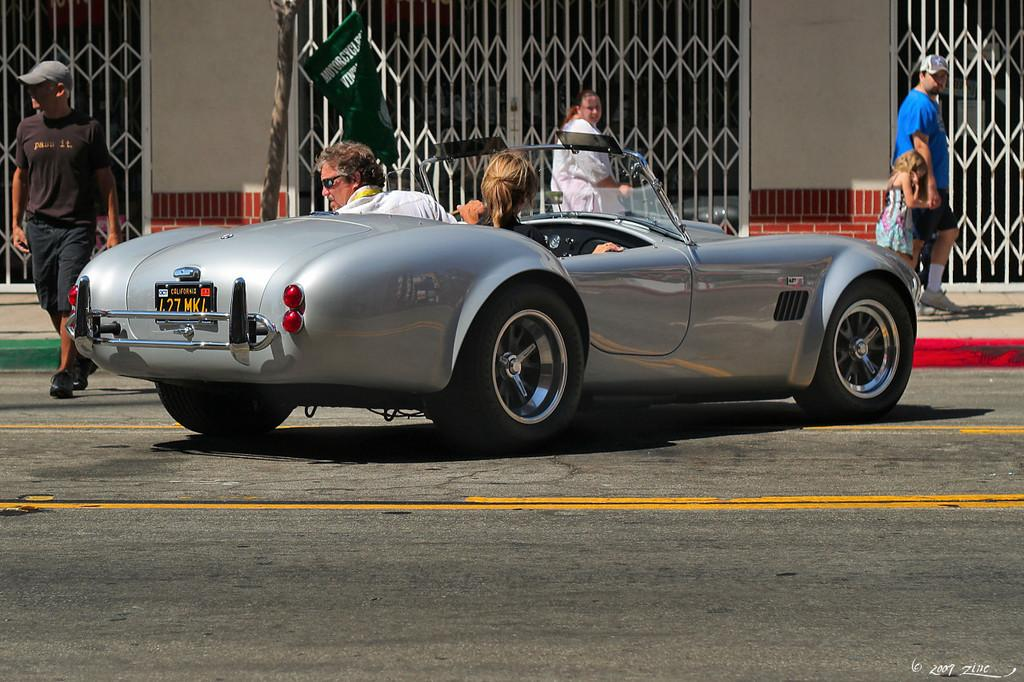How many people are inside the car in the image? There are two persons inside the car in the image. How many people are present in total in the image? There are four persons in total in the image. What can be seen in the background of the image? There is a wall and a gate in the background of the image. What is the primary setting of the image? The primary setting of the image is a road. What grade of caption is present in the image? There is no caption present in the image, so it is not possible to determine the grade. 